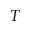<formula> <loc_0><loc_0><loc_500><loc_500>T</formula> 